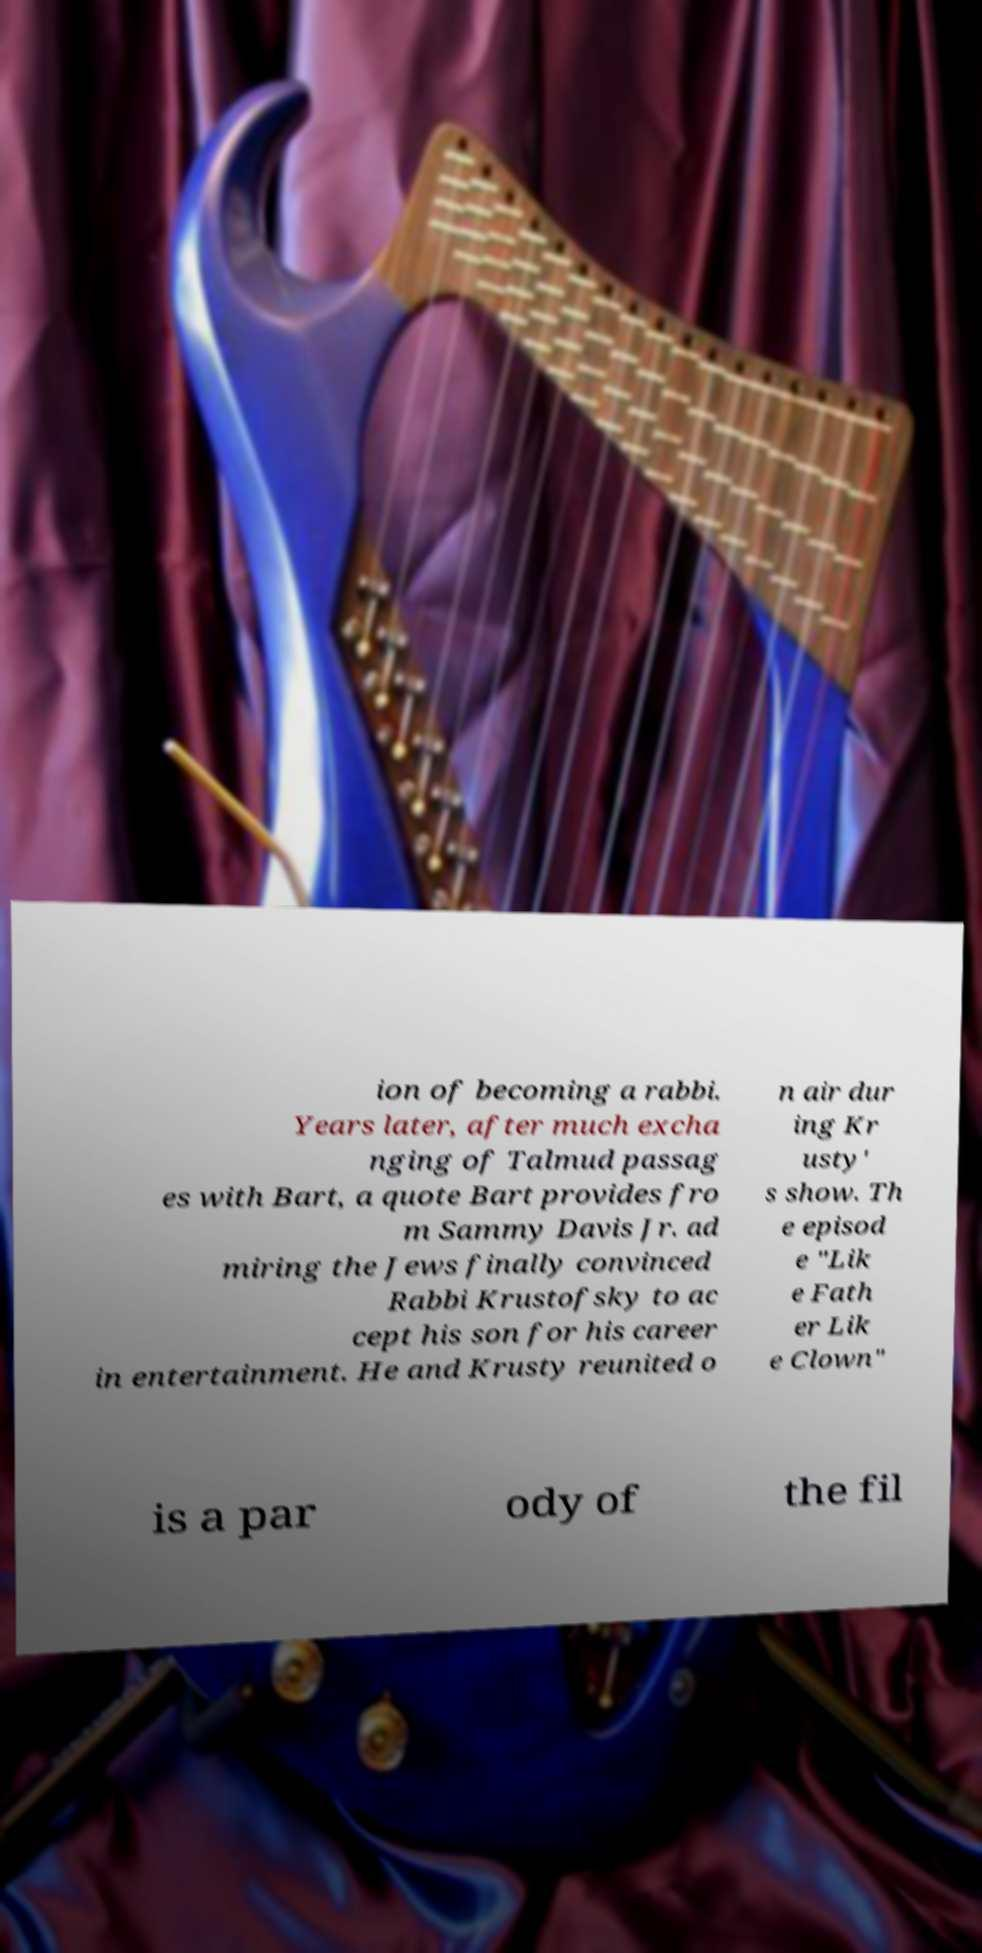Please read and relay the text visible in this image. What does it say? ion of becoming a rabbi. Years later, after much excha nging of Talmud passag es with Bart, a quote Bart provides fro m Sammy Davis Jr. ad miring the Jews finally convinced Rabbi Krustofsky to ac cept his son for his career in entertainment. He and Krusty reunited o n air dur ing Kr usty' s show. Th e episod e "Lik e Fath er Lik e Clown" is a par ody of the fil 